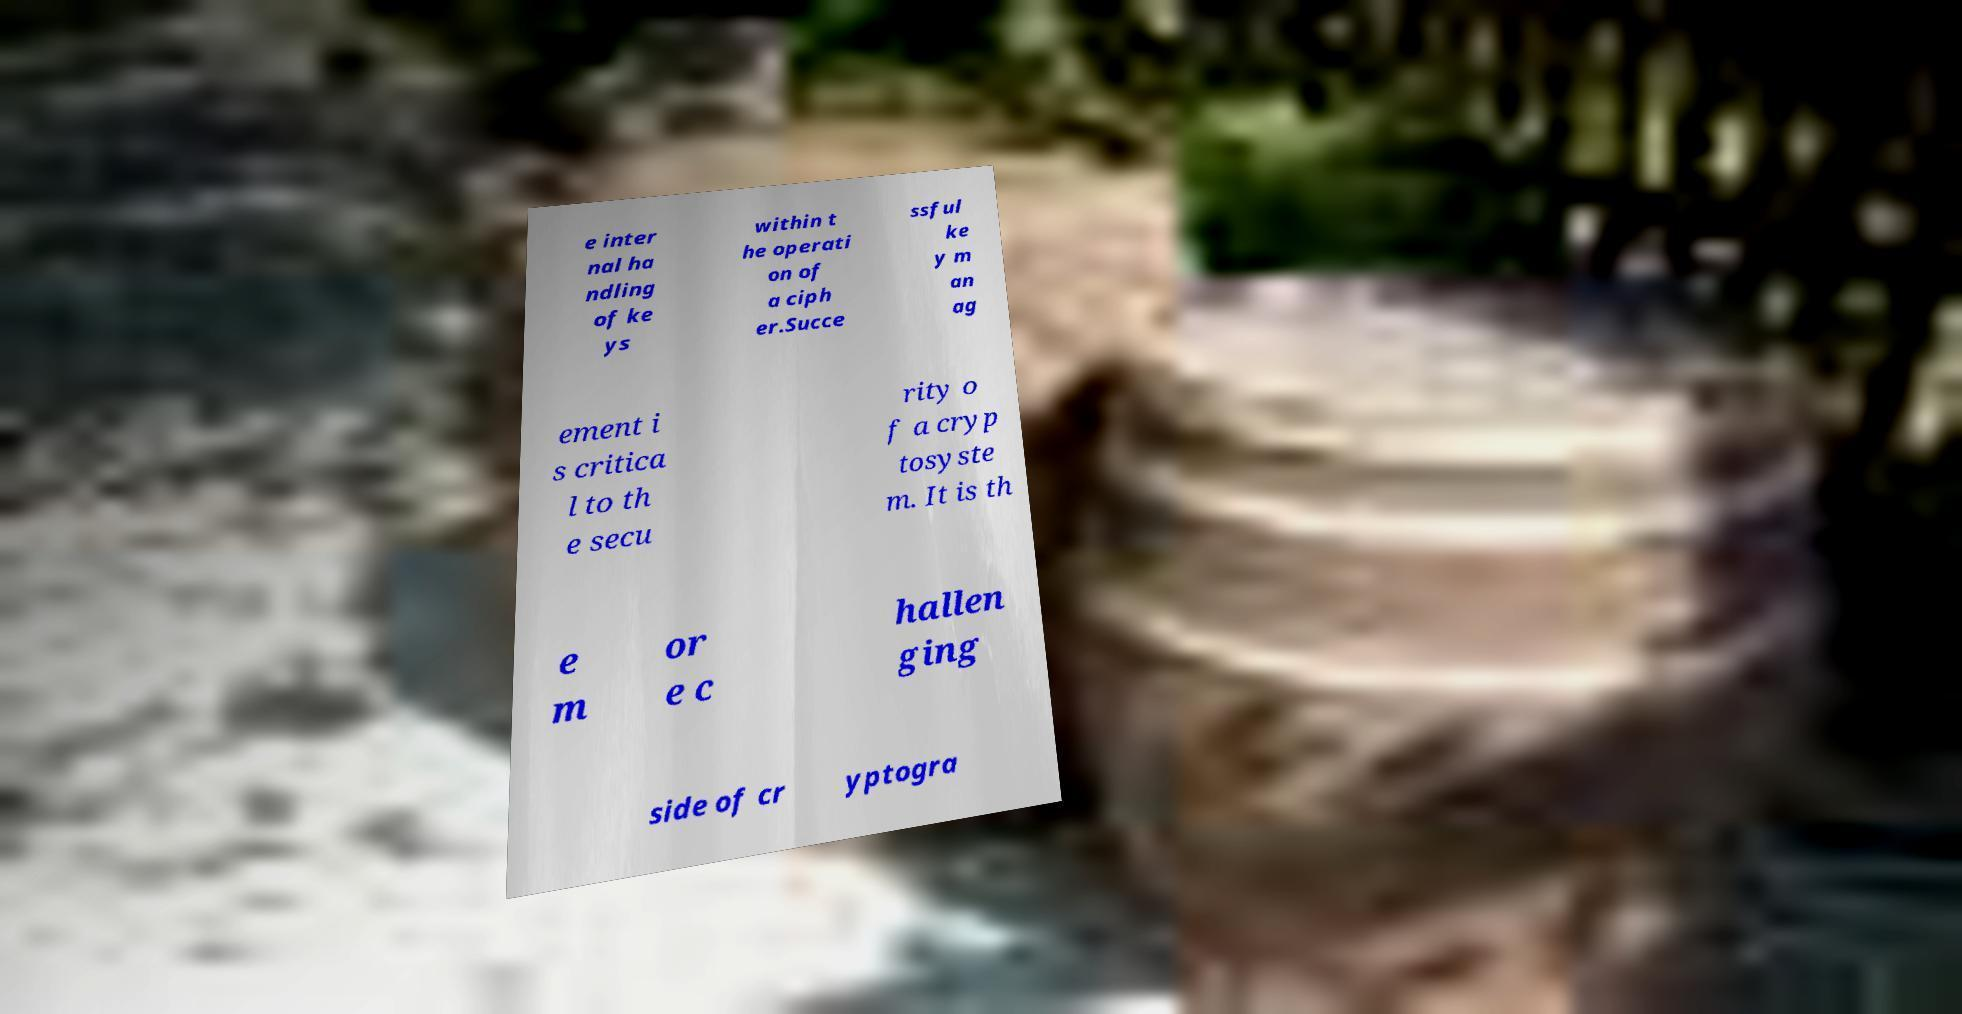Please identify and transcribe the text found in this image. e inter nal ha ndling of ke ys within t he operati on of a ciph er.Succe ssful ke y m an ag ement i s critica l to th e secu rity o f a cryp tosyste m. It is th e m or e c hallen ging side of cr yptogra 